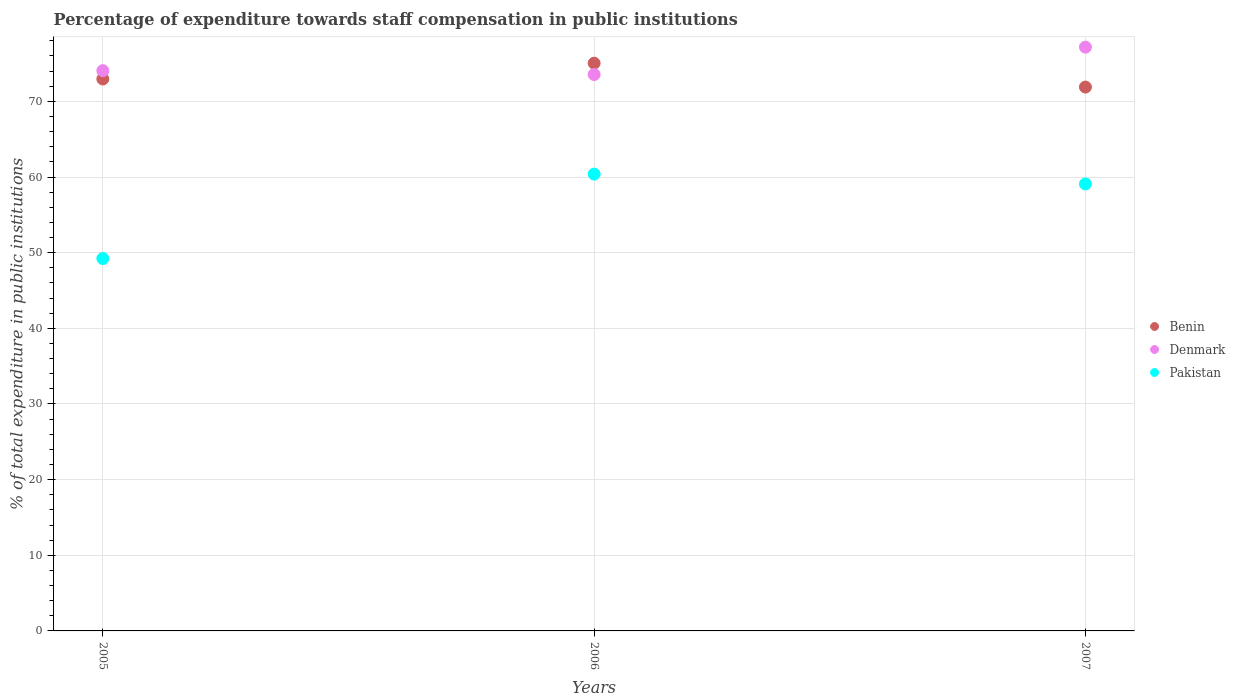What is the percentage of expenditure towards staff compensation in Benin in 2005?
Give a very brief answer. 72.96. Across all years, what is the maximum percentage of expenditure towards staff compensation in Pakistan?
Give a very brief answer. 60.39. Across all years, what is the minimum percentage of expenditure towards staff compensation in Pakistan?
Give a very brief answer. 49.23. In which year was the percentage of expenditure towards staff compensation in Denmark maximum?
Give a very brief answer. 2007. In which year was the percentage of expenditure towards staff compensation in Benin minimum?
Your answer should be very brief. 2007. What is the total percentage of expenditure towards staff compensation in Pakistan in the graph?
Your answer should be compact. 168.71. What is the difference between the percentage of expenditure towards staff compensation in Denmark in 2005 and that in 2007?
Your answer should be compact. -3.11. What is the difference between the percentage of expenditure towards staff compensation in Pakistan in 2005 and the percentage of expenditure towards staff compensation in Denmark in 2007?
Give a very brief answer. -27.94. What is the average percentage of expenditure towards staff compensation in Benin per year?
Offer a terse response. 73.3. In the year 2007, what is the difference between the percentage of expenditure towards staff compensation in Pakistan and percentage of expenditure towards staff compensation in Benin?
Offer a terse response. -12.8. In how many years, is the percentage of expenditure towards staff compensation in Benin greater than 4 %?
Your response must be concise. 3. What is the ratio of the percentage of expenditure towards staff compensation in Benin in 2005 to that in 2007?
Offer a very short reply. 1.01. What is the difference between the highest and the second highest percentage of expenditure towards staff compensation in Benin?
Keep it short and to the point. 2.09. What is the difference between the highest and the lowest percentage of expenditure towards staff compensation in Benin?
Your response must be concise. 3.15. In how many years, is the percentage of expenditure towards staff compensation in Benin greater than the average percentage of expenditure towards staff compensation in Benin taken over all years?
Offer a terse response. 1. Is the sum of the percentage of expenditure towards staff compensation in Benin in 2006 and 2007 greater than the maximum percentage of expenditure towards staff compensation in Denmark across all years?
Offer a terse response. Yes. Is it the case that in every year, the sum of the percentage of expenditure towards staff compensation in Denmark and percentage of expenditure towards staff compensation in Pakistan  is greater than the percentage of expenditure towards staff compensation in Benin?
Offer a very short reply. Yes. Is the percentage of expenditure towards staff compensation in Pakistan strictly greater than the percentage of expenditure towards staff compensation in Denmark over the years?
Your response must be concise. No. Is the percentage of expenditure towards staff compensation in Pakistan strictly less than the percentage of expenditure towards staff compensation in Benin over the years?
Ensure brevity in your answer.  Yes. How many dotlines are there?
Give a very brief answer. 3. How many years are there in the graph?
Offer a very short reply. 3. Where does the legend appear in the graph?
Make the answer very short. Center right. How many legend labels are there?
Provide a short and direct response. 3. What is the title of the graph?
Your response must be concise. Percentage of expenditure towards staff compensation in public institutions. What is the label or title of the X-axis?
Your answer should be compact. Years. What is the label or title of the Y-axis?
Your answer should be very brief. % of total expenditure in public institutions. What is the % of total expenditure in public institutions of Benin in 2005?
Your answer should be very brief. 72.96. What is the % of total expenditure in public institutions in Denmark in 2005?
Provide a short and direct response. 74.06. What is the % of total expenditure in public institutions in Pakistan in 2005?
Give a very brief answer. 49.23. What is the % of total expenditure in public institutions in Benin in 2006?
Give a very brief answer. 75.05. What is the % of total expenditure in public institutions in Denmark in 2006?
Provide a succinct answer. 73.55. What is the % of total expenditure in public institutions of Pakistan in 2006?
Keep it short and to the point. 60.39. What is the % of total expenditure in public institutions in Benin in 2007?
Keep it short and to the point. 71.89. What is the % of total expenditure in public institutions of Denmark in 2007?
Offer a terse response. 77.17. What is the % of total expenditure in public institutions in Pakistan in 2007?
Offer a very short reply. 59.09. Across all years, what is the maximum % of total expenditure in public institutions in Benin?
Provide a short and direct response. 75.05. Across all years, what is the maximum % of total expenditure in public institutions in Denmark?
Keep it short and to the point. 77.17. Across all years, what is the maximum % of total expenditure in public institutions in Pakistan?
Offer a very short reply. 60.39. Across all years, what is the minimum % of total expenditure in public institutions of Benin?
Keep it short and to the point. 71.89. Across all years, what is the minimum % of total expenditure in public institutions of Denmark?
Your response must be concise. 73.55. Across all years, what is the minimum % of total expenditure in public institutions in Pakistan?
Provide a short and direct response. 49.23. What is the total % of total expenditure in public institutions of Benin in the graph?
Provide a short and direct response. 219.9. What is the total % of total expenditure in public institutions in Denmark in the graph?
Offer a terse response. 224.79. What is the total % of total expenditure in public institutions in Pakistan in the graph?
Keep it short and to the point. 168.71. What is the difference between the % of total expenditure in public institutions of Benin in 2005 and that in 2006?
Make the answer very short. -2.09. What is the difference between the % of total expenditure in public institutions in Denmark in 2005 and that in 2006?
Provide a short and direct response. 0.51. What is the difference between the % of total expenditure in public institutions in Pakistan in 2005 and that in 2006?
Give a very brief answer. -11.16. What is the difference between the % of total expenditure in public institutions of Benin in 2005 and that in 2007?
Offer a very short reply. 1.07. What is the difference between the % of total expenditure in public institutions in Denmark in 2005 and that in 2007?
Your answer should be compact. -3.11. What is the difference between the % of total expenditure in public institutions of Pakistan in 2005 and that in 2007?
Your answer should be compact. -9.86. What is the difference between the % of total expenditure in public institutions of Benin in 2006 and that in 2007?
Your answer should be very brief. 3.15. What is the difference between the % of total expenditure in public institutions of Denmark in 2006 and that in 2007?
Ensure brevity in your answer.  -3.62. What is the difference between the % of total expenditure in public institutions in Pakistan in 2006 and that in 2007?
Make the answer very short. 1.3. What is the difference between the % of total expenditure in public institutions in Benin in 2005 and the % of total expenditure in public institutions in Denmark in 2006?
Provide a short and direct response. -0.59. What is the difference between the % of total expenditure in public institutions in Benin in 2005 and the % of total expenditure in public institutions in Pakistan in 2006?
Ensure brevity in your answer.  12.57. What is the difference between the % of total expenditure in public institutions in Denmark in 2005 and the % of total expenditure in public institutions in Pakistan in 2006?
Provide a succinct answer. 13.68. What is the difference between the % of total expenditure in public institutions of Benin in 2005 and the % of total expenditure in public institutions of Denmark in 2007?
Your answer should be compact. -4.21. What is the difference between the % of total expenditure in public institutions in Benin in 2005 and the % of total expenditure in public institutions in Pakistan in 2007?
Your answer should be compact. 13.87. What is the difference between the % of total expenditure in public institutions in Denmark in 2005 and the % of total expenditure in public institutions in Pakistan in 2007?
Provide a short and direct response. 14.97. What is the difference between the % of total expenditure in public institutions of Benin in 2006 and the % of total expenditure in public institutions of Denmark in 2007?
Offer a terse response. -2.12. What is the difference between the % of total expenditure in public institutions in Benin in 2006 and the % of total expenditure in public institutions in Pakistan in 2007?
Offer a very short reply. 15.96. What is the difference between the % of total expenditure in public institutions in Denmark in 2006 and the % of total expenditure in public institutions in Pakistan in 2007?
Ensure brevity in your answer.  14.46. What is the average % of total expenditure in public institutions in Benin per year?
Provide a succinct answer. 73.3. What is the average % of total expenditure in public institutions of Denmark per year?
Make the answer very short. 74.93. What is the average % of total expenditure in public institutions of Pakistan per year?
Your answer should be very brief. 56.24. In the year 2005, what is the difference between the % of total expenditure in public institutions of Benin and % of total expenditure in public institutions of Denmark?
Offer a terse response. -1.1. In the year 2005, what is the difference between the % of total expenditure in public institutions in Benin and % of total expenditure in public institutions in Pakistan?
Give a very brief answer. 23.73. In the year 2005, what is the difference between the % of total expenditure in public institutions of Denmark and % of total expenditure in public institutions of Pakistan?
Give a very brief answer. 24.83. In the year 2006, what is the difference between the % of total expenditure in public institutions of Benin and % of total expenditure in public institutions of Denmark?
Keep it short and to the point. 1.5. In the year 2006, what is the difference between the % of total expenditure in public institutions in Benin and % of total expenditure in public institutions in Pakistan?
Provide a succinct answer. 14.66. In the year 2006, what is the difference between the % of total expenditure in public institutions of Denmark and % of total expenditure in public institutions of Pakistan?
Provide a short and direct response. 13.17. In the year 2007, what is the difference between the % of total expenditure in public institutions in Benin and % of total expenditure in public institutions in Denmark?
Your response must be concise. -5.28. In the year 2007, what is the difference between the % of total expenditure in public institutions in Benin and % of total expenditure in public institutions in Pakistan?
Offer a very short reply. 12.8. In the year 2007, what is the difference between the % of total expenditure in public institutions of Denmark and % of total expenditure in public institutions of Pakistan?
Provide a succinct answer. 18.08. What is the ratio of the % of total expenditure in public institutions in Benin in 2005 to that in 2006?
Give a very brief answer. 0.97. What is the ratio of the % of total expenditure in public institutions of Denmark in 2005 to that in 2006?
Offer a terse response. 1.01. What is the ratio of the % of total expenditure in public institutions in Pakistan in 2005 to that in 2006?
Keep it short and to the point. 0.82. What is the ratio of the % of total expenditure in public institutions of Benin in 2005 to that in 2007?
Ensure brevity in your answer.  1.01. What is the ratio of the % of total expenditure in public institutions of Denmark in 2005 to that in 2007?
Offer a very short reply. 0.96. What is the ratio of the % of total expenditure in public institutions in Pakistan in 2005 to that in 2007?
Your response must be concise. 0.83. What is the ratio of the % of total expenditure in public institutions in Benin in 2006 to that in 2007?
Offer a very short reply. 1.04. What is the ratio of the % of total expenditure in public institutions of Denmark in 2006 to that in 2007?
Give a very brief answer. 0.95. What is the ratio of the % of total expenditure in public institutions in Pakistan in 2006 to that in 2007?
Make the answer very short. 1.02. What is the difference between the highest and the second highest % of total expenditure in public institutions in Benin?
Your answer should be very brief. 2.09. What is the difference between the highest and the second highest % of total expenditure in public institutions in Denmark?
Your answer should be compact. 3.11. What is the difference between the highest and the second highest % of total expenditure in public institutions in Pakistan?
Your response must be concise. 1.3. What is the difference between the highest and the lowest % of total expenditure in public institutions in Benin?
Your answer should be compact. 3.15. What is the difference between the highest and the lowest % of total expenditure in public institutions in Denmark?
Make the answer very short. 3.62. What is the difference between the highest and the lowest % of total expenditure in public institutions of Pakistan?
Offer a very short reply. 11.16. 